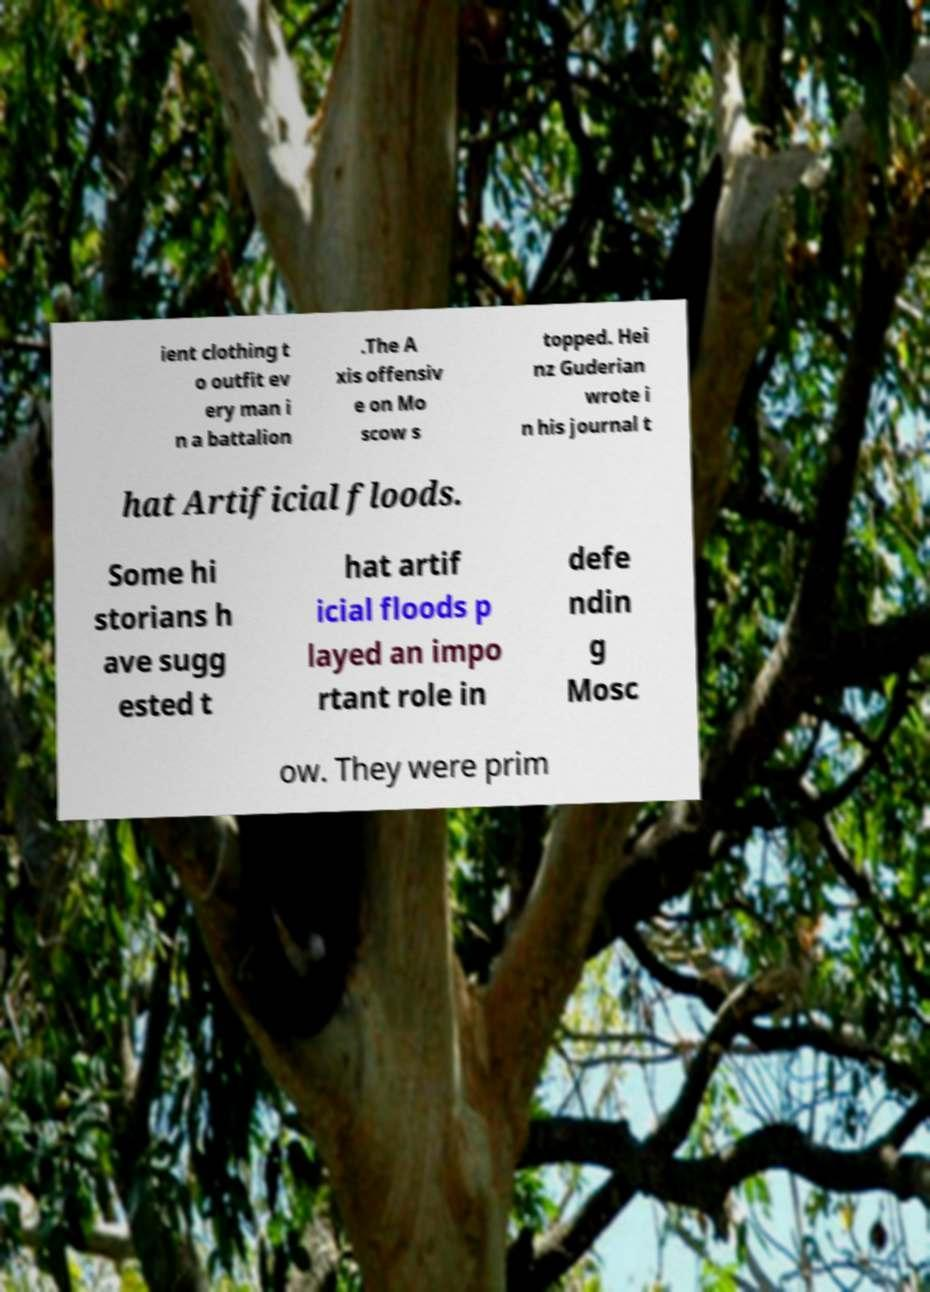Please read and relay the text visible in this image. What does it say? ient clothing t o outfit ev ery man i n a battalion .The A xis offensiv e on Mo scow s topped. Hei nz Guderian wrote i n his journal t hat Artificial floods. Some hi storians h ave sugg ested t hat artif icial floods p layed an impo rtant role in defe ndin g Mosc ow. They were prim 